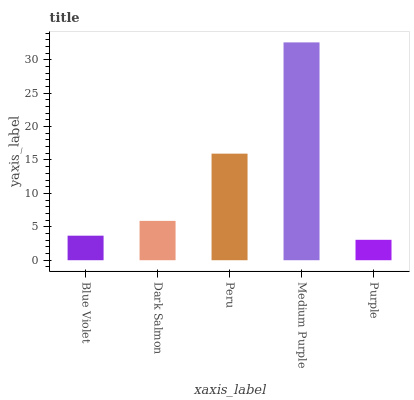Is Purple the minimum?
Answer yes or no. Yes. Is Medium Purple the maximum?
Answer yes or no. Yes. Is Dark Salmon the minimum?
Answer yes or no. No. Is Dark Salmon the maximum?
Answer yes or no. No. Is Dark Salmon greater than Blue Violet?
Answer yes or no. Yes. Is Blue Violet less than Dark Salmon?
Answer yes or no. Yes. Is Blue Violet greater than Dark Salmon?
Answer yes or no. No. Is Dark Salmon less than Blue Violet?
Answer yes or no. No. Is Dark Salmon the high median?
Answer yes or no. Yes. Is Dark Salmon the low median?
Answer yes or no. Yes. Is Peru the high median?
Answer yes or no. No. Is Blue Violet the low median?
Answer yes or no. No. 